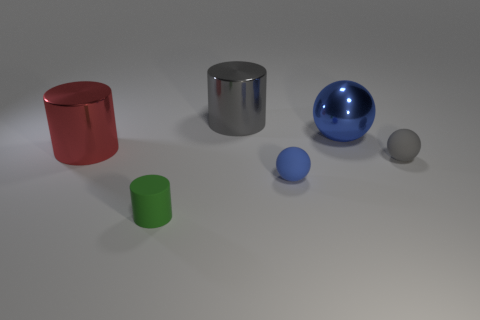How many blue things are either large rubber balls or tiny rubber objects?
Give a very brief answer. 1. Are there any other balls of the same color as the large metallic ball?
Make the answer very short. Yes. Are there any big red cylinders that have the same material as the large gray object?
Your answer should be compact. Yes. There is a large thing that is right of the green cylinder and in front of the gray cylinder; what shape is it?
Make the answer very short. Sphere. How many large things are either gray shiny objects or gray objects?
Your answer should be very brief. 1. What is the tiny gray ball made of?
Provide a succinct answer. Rubber. What number of other objects are the same shape as the big red object?
Offer a very short reply. 2. What size is the red cylinder?
Your answer should be very brief. Large. What is the size of the metallic object that is both in front of the large gray object and behind the large red object?
Ensure brevity in your answer.  Large. There is a gray object behind the metallic sphere; what is its shape?
Make the answer very short. Cylinder. 